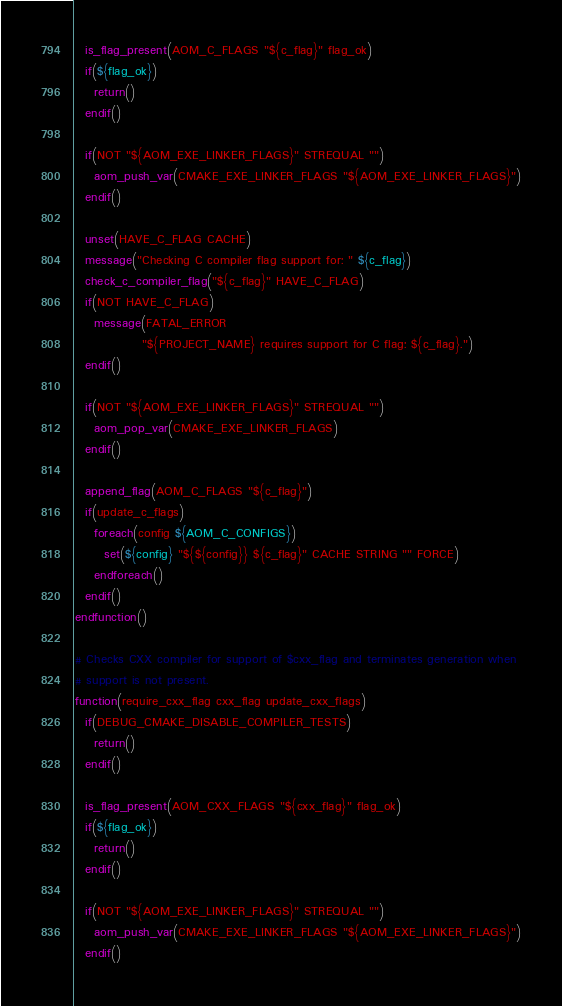Convert code to text. <code><loc_0><loc_0><loc_500><loc_500><_CMake_>
  is_flag_present(AOM_C_FLAGS "${c_flag}" flag_ok)
  if(${flag_ok})
    return()
  endif()

  if(NOT "${AOM_EXE_LINKER_FLAGS}" STREQUAL "")
    aom_push_var(CMAKE_EXE_LINKER_FLAGS "${AOM_EXE_LINKER_FLAGS}")
  endif()

  unset(HAVE_C_FLAG CACHE)
  message("Checking C compiler flag support for: " ${c_flag})
  check_c_compiler_flag("${c_flag}" HAVE_C_FLAG)
  if(NOT HAVE_C_FLAG)
    message(FATAL_ERROR
              "${PROJECT_NAME} requires support for C flag: ${c_flag}.")
  endif()

  if(NOT "${AOM_EXE_LINKER_FLAGS}" STREQUAL "")
    aom_pop_var(CMAKE_EXE_LINKER_FLAGS)
  endif()

  append_flag(AOM_C_FLAGS "${c_flag}")
  if(update_c_flags)
    foreach(config ${AOM_C_CONFIGS})
      set(${config} "${${config}} ${c_flag}" CACHE STRING "" FORCE)
    endforeach()
  endif()
endfunction()

# Checks CXX compiler for support of $cxx_flag and terminates generation when
# support is not present.
function(require_cxx_flag cxx_flag update_cxx_flags)
  if(DEBUG_CMAKE_DISABLE_COMPILER_TESTS)
    return()
  endif()

  is_flag_present(AOM_CXX_FLAGS "${cxx_flag}" flag_ok)
  if(${flag_ok})
    return()
  endif()

  if(NOT "${AOM_EXE_LINKER_FLAGS}" STREQUAL "")
    aom_push_var(CMAKE_EXE_LINKER_FLAGS "${AOM_EXE_LINKER_FLAGS}")
  endif()
</code> 